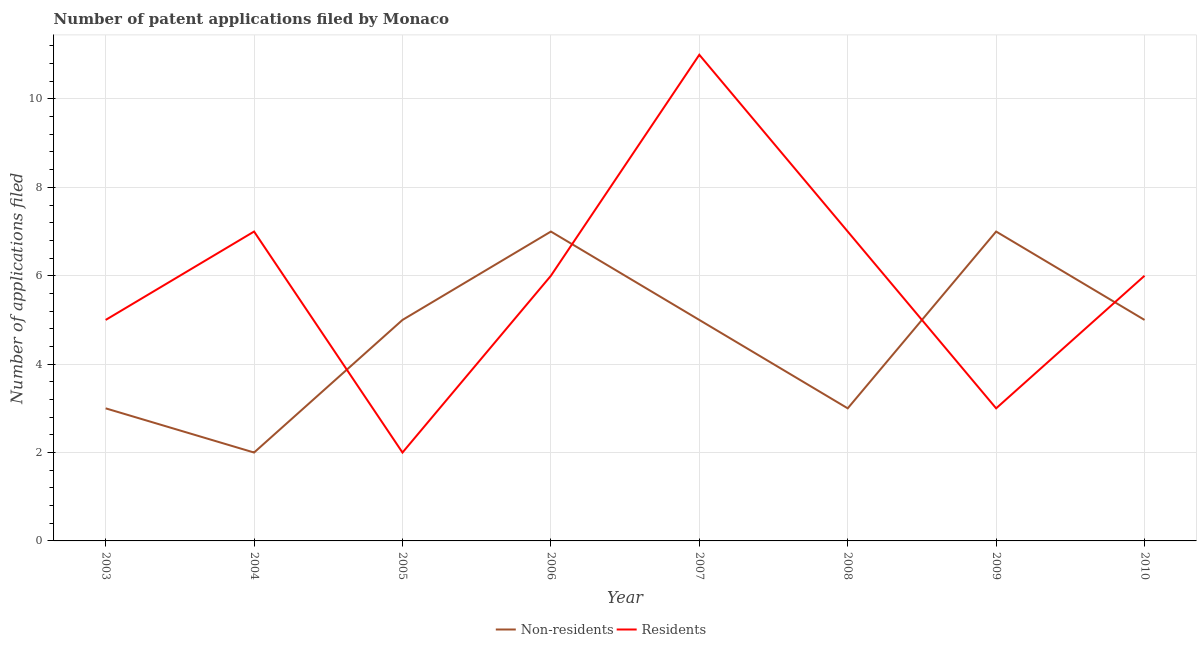How many different coloured lines are there?
Your answer should be compact. 2. What is the number of patent applications by residents in 2004?
Your response must be concise. 7. Across all years, what is the maximum number of patent applications by non residents?
Provide a succinct answer. 7. Across all years, what is the minimum number of patent applications by non residents?
Ensure brevity in your answer.  2. In which year was the number of patent applications by non residents maximum?
Offer a very short reply. 2006. In which year was the number of patent applications by residents minimum?
Keep it short and to the point. 2005. What is the total number of patent applications by non residents in the graph?
Your answer should be very brief. 37. What is the difference between the number of patent applications by non residents in 2004 and that in 2005?
Provide a succinct answer. -3. What is the difference between the number of patent applications by residents in 2007 and the number of patent applications by non residents in 2005?
Offer a terse response. 6. What is the average number of patent applications by residents per year?
Make the answer very short. 5.88. In the year 2004, what is the difference between the number of patent applications by non residents and number of patent applications by residents?
Provide a succinct answer. -5. In how many years, is the number of patent applications by residents greater than 2.8?
Offer a very short reply. 7. What is the ratio of the number of patent applications by residents in 2003 to that in 2009?
Offer a terse response. 1.67. Is the number of patent applications by non residents in 2005 less than that in 2010?
Provide a short and direct response. No. What is the difference between the highest and the second highest number of patent applications by non residents?
Keep it short and to the point. 0. What is the difference between the highest and the lowest number of patent applications by non residents?
Make the answer very short. 5. In how many years, is the number of patent applications by residents greater than the average number of patent applications by residents taken over all years?
Your response must be concise. 5. Is the number of patent applications by non residents strictly less than the number of patent applications by residents over the years?
Give a very brief answer. No. How many years are there in the graph?
Give a very brief answer. 8. What is the difference between two consecutive major ticks on the Y-axis?
Your answer should be very brief. 2. Are the values on the major ticks of Y-axis written in scientific E-notation?
Your answer should be very brief. No. Does the graph contain any zero values?
Your response must be concise. No. How many legend labels are there?
Your answer should be compact. 2. What is the title of the graph?
Make the answer very short. Number of patent applications filed by Monaco. Does "constant 2005 US$" appear as one of the legend labels in the graph?
Keep it short and to the point. No. What is the label or title of the X-axis?
Offer a very short reply. Year. What is the label or title of the Y-axis?
Make the answer very short. Number of applications filed. What is the Number of applications filed in Non-residents in 2005?
Provide a short and direct response. 5. What is the Number of applications filed in Residents in 2005?
Your answer should be compact. 2. What is the Number of applications filed in Non-residents in 2006?
Make the answer very short. 7. What is the Number of applications filed in Residents in 2006?
Offer a very short reply. 6. What is the Number of applications filed of Residents in 2007?
Provide a succinct answer. 11. What is the Number of applications filed in Residents in 2008?
Make the answer very short. 7. What is the Number of applications filed in Non-residents in 2009?
Ensure brevity in your answer.  7. What is the Number of applications filed of Non-residents in 2010?
Your response must be concise. 5. Across all years, what is the minimum Number of applications filed in Non-residents?
Make the answer very short. 2. What is the difference between the Number of applications filed of Non-residents in 2003 and that in 2004?
Keep it short and to the point. 1. What is the difference between the Number of applications filed of Residents in 2003 and that in 2004?
Your answer should be compact. -2. What is the difference between the Number of applications filed of Non-residents in 2003 and that in 2005?
Give a very brief answer. -2. What is the difference between the Number of applications filed in Non-residents in 2003 and that in 2007?
Provide a succinct answer. -2. What is the difference between the Number of applications filed of Non-residents in 2003 and that in 2008?
Offer a terse response. 0. What is the difference between the Number of applications filed in Non-residents in 2003 and that in 2009?
Make the answer very short. -4. What is the difference between the Number of applications filed of Residents in 2003 and that in 2009?
Offer a terse response. 2. What is the difference between the Number of applications filed of Non-residents in 2003 and that in 2010?
Ensure brevity in your answer.  -2. What is the difference between the Number of applications filed in Non-residents in 2004 and that in 2006?
Offer a very short reply. -5. What is the difference between the Number of applications filed of Non-residents in 2004 and that in 2007?
Provide a succinct answer. -3. What is the difference between the Number of applications filed of Non-residents in 2004 and that in 2008?
Ensure brevity in your answer.  -1. What is the difference between the Number of applications filed in Non-residents in 2004 and that in 2009?
Offer a very short reply. -5. What is the difference between the Number of applications filed in Residents in 2004 and that in 2009?
Your answer should be compact. 4. What is the difference between the Number of applications filed in Residents in 2004 and that in 2010?
Make the answer very short. 1. What is the difference between the Number of applications filed of Non-residents in 2005 and that in 2006?
Provide a short and direct response. -2. What is the difference between the Number of applications filed of Residents in 2005 and that in 2006?
Your response must be concise. -4. What is the difference between the Number of applications filed of Residents in 2005 and that in 2007?
Provide a succinct answer. -9. What is the difference between the Number of applications filed of Non-residents in 2005 and that in 2008?
Give a very brief answer. 2. What is the difference between the Number of applications filed in Non-residents in 2005 and that in 2010?
Provide a short and direct response. 0. What is the difference between the Number of applications filed in Residents in 2005 and that in 2010?
Offer a very short reply. -4. What is the difference between the Number of applications filed in Non-residents in 2006 and that in 2007?
Provide a short and direct response. 2. What is the difference between the Number of applications filed in Residents in 2006 and that in 2007?
Offer a terse response. -5. What is the difference between the Number of applications filed of Non-residents in 2006 and that in 2008?
Keep it short and to the point. 4. What is the difference between the Number of applications filed of Residents in 2006 and that in 2008?
Offer a very short reply. -1. What is the difference between the Number of applications filed of Residents in 2006 and that in 2009?
Your answer should be very brief. 3. What is the difference between the Number of applications filed in Residents in 2006 and that in 2010?
Your response must be concise. 0. What is the difference between the Number of applications filed in Non-residents in 2007 and that in 2008?
Offer a very short reply. 2. What is the difference between the Number of applications filed in Residents in 2007 and that in 2008?
Provide a succinct answer. 4. What is the difference between the Number of applications filed in Non-residents in 2007 and that in 2009?
Ensure brevity in your answer.  -2. What is the difference between the Number of applications filed of Residents in 2007 and that in 2009?
Provide a succinct answer. 8. What is the difference between the Number of applications filed of Non-residents in 2008 and that in 2009?
Your answer should be very brief. -4. What is the difference between the Number of applications filed of Non-residents in 2008 and that in 2010?
Your answer should be compact. -2. What is the difference between the Number of applications filed in Residents in 2008 and that in 2010?
Offer a terse response. 1. What is the difference between the Number of applications filed in Residents in 2009 and that in 2010?
Your response must be concise. -3. What is the difference between the Number of applications filed of Non-residents in 2003 and the Number of applications filed of Residents in 2006?
Your answer should be compact. -3. What is the difference between the Number of applications filed of Non-residents in 2003 and the Number of applications filed of Residents in 2007?
Give a very brief answer. -8. What is the difference between the Number of applications filed in Non-residents in 2003 and the Number of applications filed in Residents in 2008?
Your answer should be compact. -4. What is the difference between the Number of applications filed in Non-residents in 2004 and the Number of applications filed in Residents in 2006?
Give a very brief answer. -4. What is the difference between the Number of applications filed in Non-residents in 2004 and the Number of applications filed in Residents in 2008?
Give a very brief answer. -5. What is the difference between the Number of applications filed in Non-residents in 2004 and the Number of applications filed in Residents in 2009?
Ensure brevity in your answer.  -1. What is the difference between the Number of applications filed of Non-residents in 2005 and the Number of applications filed of Residents in 2008?
Your answer should be compact. -2. What is the difference between the Number of applications filed of Non-residents in 2006 and the Number of applications filed of Residents in 2008?
Offer a very short reply. 0. What is the difference between the Number of applications filed of Non-residents in 2006 and the Number of applications filed of Residents in 2010?
Give a very brief answer. 1. What is the difference between the Number of applications filed in Non-residents in 2007 and the Number of applications filed in Residents in 2008?
Your response must be concise. -2. What is the difference between the Number of applications filed in Non-residents in 2007 and the Number of applications filed in Residents in 2009?
Make the answer very short. 2. What is the difference between the Number of applications filed of Non-residents in 2007 and the Number of applications filed of Residents in 2010?
Offer a terse response. -1. What is the difference between the Number of applications filed in Non-residents in 2008 and the Number of applications filed in Residents in 2009?
Provide a short and direct response. 0. What is the difference between the Number of applications filed in Non-residents in 2008 and the Number of applications filed in Residents in 2010?
Offer a terse response. -3. What is the difference between the Number of applications filed of Non-residents in 2009 and the Number of applications filed of Residents in 2010?
Your response must be concise. 1. What is the average Number of applications filed in Non-residents per year?
Offer a very short reply. 4.62. What is the average Number of applications filed of Residents per year?
Offer a very short reply. 5.88. In the year 2004, what is the difference between the Number of applications filed in Non-residents and Number of applications filed in Residents?
Provide a succinct answer. -5. In the year 2006, what is the difference between the Number of applications filed of Non-residents and Number of applications filed of Residents?
Keep it short and to the point. 1. In the year 2008, what is the difference between the Number of applications filed in Non-residents and Number of applications filed in Residents?
Your answer should be compact. -4. In the year 2009, what is the difference between the Number of applications filed in Non-residents and Number of applications filed in Residents?
Provide a short and direct response. 4. In the year 2010, what is the difference between the Number of applications filed of Non-residents and Number of applications filed of Residents?
Make the answer very short. -1. What is the ratio of the Number of applications filed of Non-residents in 2003 to that in 2004?
Keep it short and to the point. 1.5. What is the ratio of the Number of applications filed of Residents in 2003 to that in 2004?
Keep it short and to the point. 0.71. What is the ratio of the Number of applications filed in Non-residents in 2003 to that in 2006?
Your answer should be compact. 0.43. What is the ratio of the Number of applications filed of Residents in 2003 to that in 2006?
Give a very brief answer. 0.83. What is the ratio of the Number of applications filed in Non-residents in 2003 to that in 2007?
Your response must be concise. 0.6. What is the ratio of the Number of applications filed in Residents in 2003 to that in 2007?
Offer a very short reply. 0.45. What is the ratio of the Number of applications filed of Non-residents in 2003 to that in 2008?
Make the answer very short. 1. What is the ratio of the Number of applications filed of Residents in 2003 to that in 2008?
Offer a very short reply. 0.71. What is the ratio of the Number of applications filed of Non-residents in 2003 to that in 2009?
Keep it short and to the point. 0.43. What is the ratio of the Number of applications filed of Non-residents in 2003 to that in 2010?
Your answer should be very brief. 0.6. What is the ratio of the Number of applications filed in Non-residents in 2004 to that in 2006?
Keep it short and to the point. 0.29. What is the ratio of the Number of applications filed in Residents in 2004 to that in 2006?
Give a very brief answer. 1.17. What is the ratio of the Number of applications filed of Residents in 2004 to that in 2007?
Your answer should be very brief. 0.64. What is the ratio of the Number of applications filed in Non-residents in 2004 to that in 2009?
Your answer should be very brief. 0.29. What is the ratio of the Number of applications filed of Residents in 2004 to that in 2009?
Make the answer very short. 2.33. What is the ratio of the Number of applications filed in Non-residents in 2004 to that in 2010?
Provide a short and direct response. 0.4. What is the ratio of the Number of applications filed in Residents in 2004 to that in 2010?
Your answer should be very brief. 1.17. What is the ratio of the Number of applications filed in Non-residents in 2005 to that in 2006?
Keep it short and to the point. 0.71. What is the ratio of the Number of applications filed of Non-residents in 2005 to that in 2007?
Offer a terse response. 1. What is the ratio of the Number of applications filed of Residents in 2005 to that in 2007?
Your response must be concise. 0.18. What is the ratio of the Number of applications filed in Residents in 2005 to that in 2008?
Make the answer very short. 0.29. What is the ratio of the Number of applications filed of Non-residents in 2005 to that in 2009?
Offer a terse response. 0.71. What is the ratio of the Number of applications filed of Residents in 2005 to that in 2009?
Your answer should be very brief. 0.67. What is the ratio of the Number of applications filed in Non-residents in 2005 to that in 2010?
Provide a succinct answer. 1. What is the ratio of the Number of applications filed in Residents in 2005 to that in 2010?
Your answer should be compact. 0.33. What is the ratio of the Number of applications filed in Residents in 2006 to that in 2007?
Offer a terse response. 0.55. What is the ratio of the Number of applications filed in Non-residents in 2006 to that in 2008?
Ensure brevity in your answer.  2.33. What is the ratio of the Number of applications filed of Residents in 2006 to that in 2008?
Provide a short and direct response. 0.86. What is the ratio of the Number of applications filed of Non-residents in 2006 to that in 2009?
Offer a terse response. 1. What is the ratio of the Number of applications filed in Residents in 2006 to that in 2009?
Provide a succinct answer. 2. What is the ratio of the Number of applications filed of Residents in 2006 to that in 2010?
Offer a very short reply. 1. What is the ratio of the Number of applications filed in Non-residents in 2007 to that in 2008?
Your answer should be very brief. 1.67. What is the ratio of the Number of applications filed of Residents in 2007 to that in 2008?
Your answer should be compact. 1.57. What is the ratio of the Number of applications filed of Residents in 2007 to that in 2009?
Provide a short and direct response. 3.67. What is the ratio of the Number of applications filed of Residents in 2007 to that in 2010?
Your answer should be very brief. 1.83. What is the ratio of the Number of applications filed in Non-residents in 2008 to that in 2009?
Ensure brevity in your answer.  0.43. What is the ratio of the Number of applications filed of Residents in 2008 to that in 2009?
Provide a short and direct response. 2.33. What is the ratio of the Number of applications filed in Residents in 2009 to that in 2010?
Provide a short and direct response. 0.5. What is the difference between the highest and the second highest Number of applications filed of Non-residents?
Your answer should be compact. 0. What is the difference between the highest and the lowest Number of applications filed of Non-residents?
Ensure brevity in your answer.  5. 